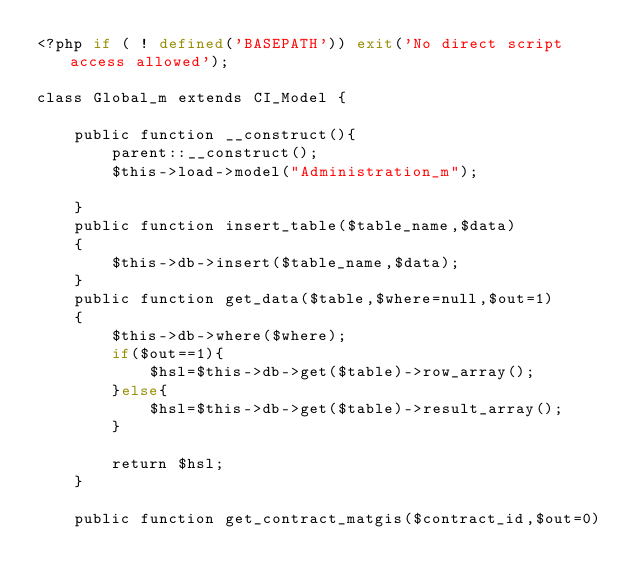Convert code to text. <code><loc_0><loc_0><loc_500><loc_500><_PHP_><?php if ( ! defined('BASEPATH')) exit('No direct script access allowed');

class Global_m extends CI_Model {

	public function __construct(){
		parent::__construct();
		$this->load->model("Administration_m");

	}
	public function insert_table($table_name,$data)
	{
		$this->db->insert($table_name,$data);
	}
	public function get_data($table,$where=null,$out=1)
	{
		$this->db->where($where);
		if($out==1){
			$hsl=$this->db->get($table)->row_array();
		}else{
			$hsl=$this->db->get($table)->result_array();
		}

		return $hsl;
	}

	public function get_contract_matgis($contract_id,$out=0)</code> 